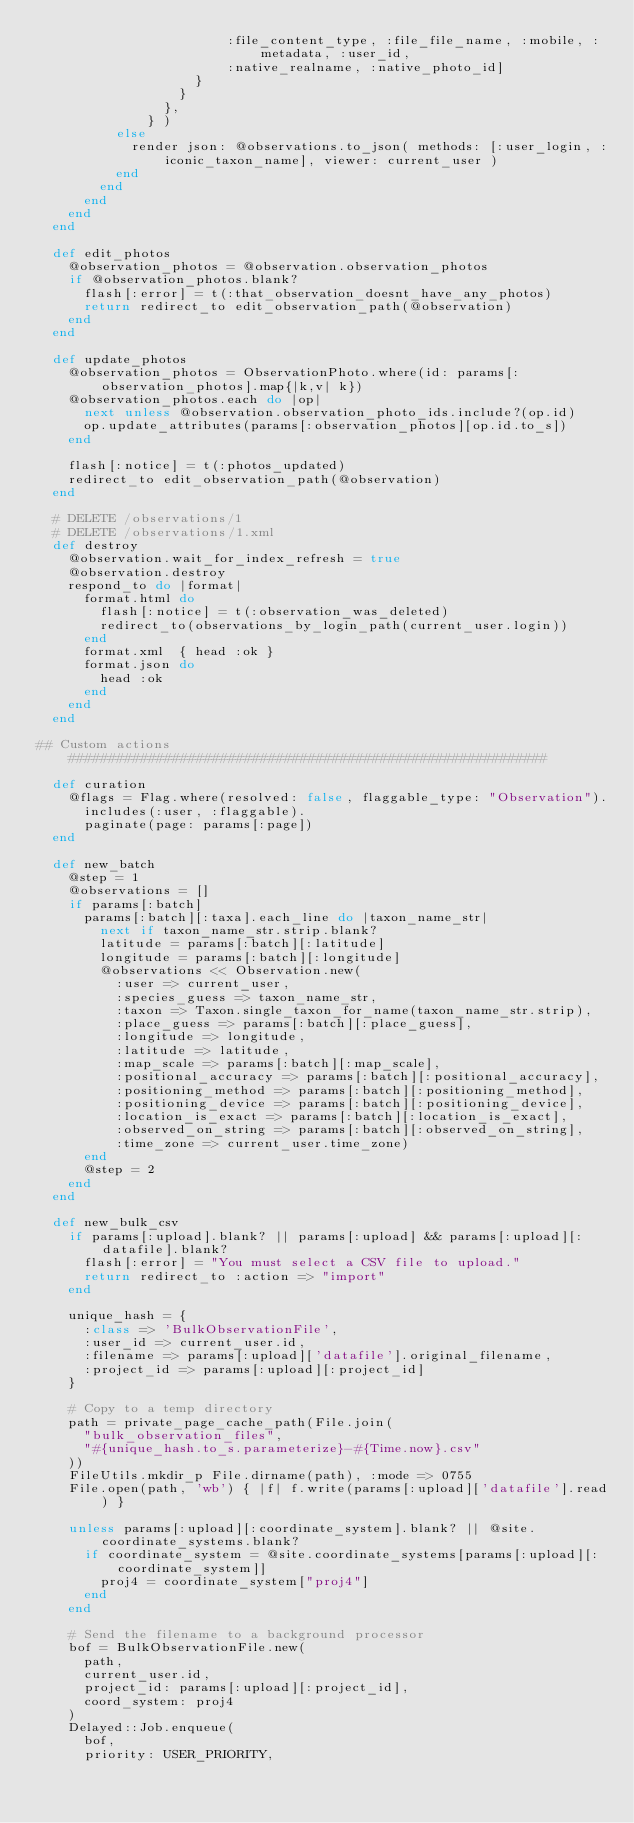Convert code to text. <code><loc_0><loc_0><loc_500><loc_500><_Ruby_>                        :file_content_type, :file_file_name, :mobile, :metadata, :user_id, 
                        :native_realname, :native_photo_id]
                    }
                  }
                },
              } )
          else
            render json: @observations.to_json( methods: [:user_login, :iconic_taxon_name], viewer: current_user )
          end
        end
      end
    end
  end
  
  def edit_photos
    @observation_photos = @observation.observation_photos
    if @observation_photos.blank?
      flash[:error] = t(:that_observation_doesnt_have_any_photos)
      return redirect_to edit_observation_path(@observation)
    end
  end
  
  def update_photos
    @observation_photos = ObservationPhoto.where(id: params[:observation_photos].map{|k,v| k})
    @observation_photos.each do |op|
      next unless @observation.observation_photo_ids.include?(op.id)
      op.update_attributes(params[:observation_photos][op.id.to_s])
    end
    
    flash[:notice] = t(:photos_updated)
    redirect_to edit_observation_path(@observation)
  end
  
  # DELETE /observations/1
  # DELETE /observations/1.xml
  def destroy
    @observation.wait_for_index_refresh = true
    @observation.destroy
    respond_to do |format|
      format.html do
        flash[:notice] = t(:observation_was_deleted)
        redirect_to(observations_by_login_path(current_user.login))
      end
      format.xml  { head :ok }
      format.json do
        head :ok
      end
    end
  end

## Custom actions ############################################################

  def curation
    @flags = Flag.where(resolved: false, flaggable_type: "Observation").
      includes(:user, :flaggable).
      paginate(page: params[:page])
  end

  def new_batch
    @step = 1
    @observations = []
    if params[:batch]
      params[:batch][:taxa].each_line do |taxon_name_str|
        next if taxon_name_str.strip.blank?
        latitude = params[:batch][:latitude]
        longitude = params[:batch][:longitude]
        @observations << Observation.new(
          :user => current_user,
          :species_guess => taxon_name_str,
          :taxon => Taxon.single_taxon_for_name(taxon_name_str.strip),
          :place_guess => params[:batch][:place_guess],
          :longitude => longitude,
          :latitude => latitude,
          :map_scale => params[:batch][:map_scale],
          :positional_accuracy => params[:batch][:positional_accuracy],
          :positioning_method => params[:batch][:positioning_method],
          :positioning_device => params[:batch][:positioning_device],
          :location_is_exact => params[:batch][:location_is_exact],
          :observed_on_string => params[:batch][:observed_on_string],
          :time_zone => current_user.time_zone)
      end
      @step = 2
    end
  end

  def new_bulk_csv
    if params[:upload].blank? || params[:upload] && params[:upload][:datafile].blank?
      flash[:error] = "You must select a CSV file to upload."
      return redirect_to :action => "import"
    end

    unique_hash = {
      :class => 'BulkObservationFile',
      :user_id => current_user.id,
      :filename => params[:upload]['datafile'].original_filename,
      :project_id => params[:upload][:project_id]
    }

    # Copy to a temp directory
    path = private_page_cache_path(File.join(
      "bulk_observation_files", 
      "#{unique_hash.to_s.parameterize}-#{Time.now}.csv"
    ))
    FileUtils.mkdir_p File.dirname(path), :mode => 0755
    File.open(path, 'wb') { |f| f.write(params[:upload]['datafile'].read) }

    unless params[:upload][:coordinate_system].blank? || @site.coordinate_systems.blank?
      if coordinate_system = @site.coordinate_systems[params[:upload][:coordinate_system]]
        proj4 = coordinate_system["proj4"]
      end
    end

    # Send the filename to a background processor
    bof = BulkObservationFile.new(
      path,
      current_user.id,
      project_id: params[:upload][:project_id], 
      coord_system: proj4
    )
    Delayed::Job.enqueue(
      bof, 
      priority: USER_PRIORITY,</code> 